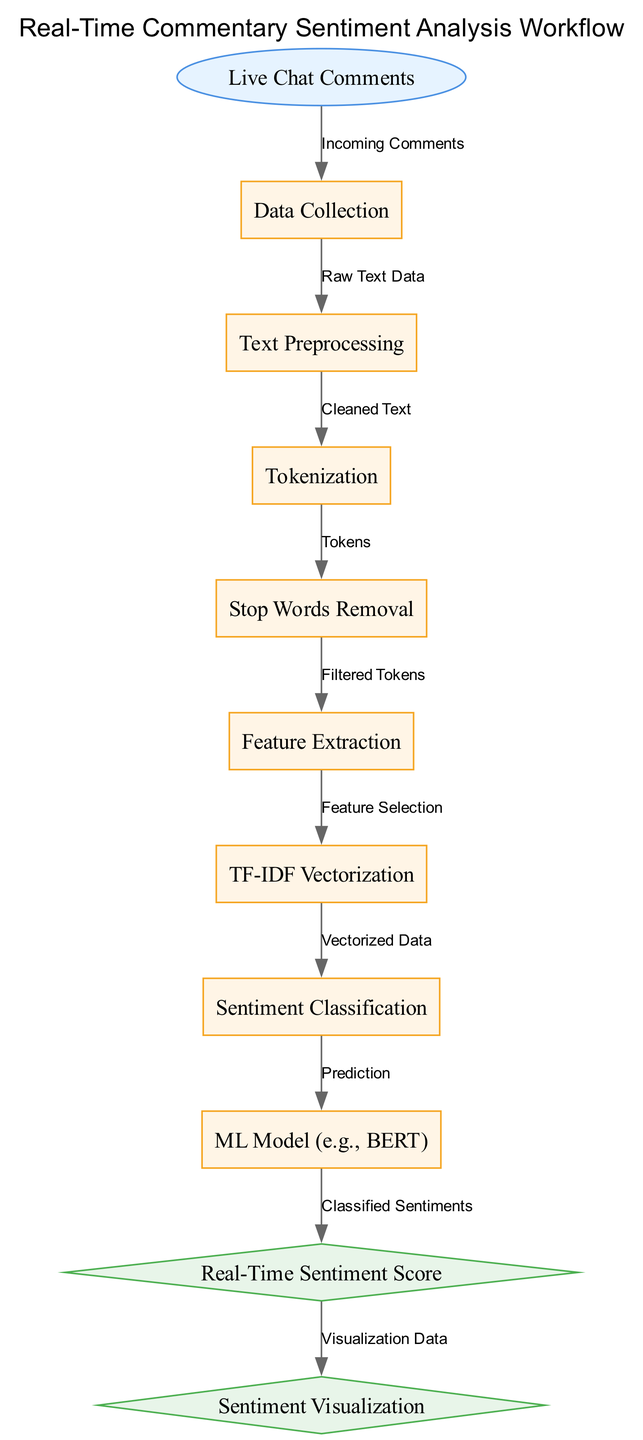What is the input for the sentiment analysis system? The diagram indicates that the input for the sentiment analysis system is "Live Chat Comments," which are collected from the streaming interface.
Answer: Live Chat Comments How many stages are there in the processing workflow? The diagram lists a total of eight processing stages: Data Collection, Text Preprocessing, Tokenization, Stop Words Removal, Feature Extraction, TF-IDF Vectorization, Sentiment Classification, and ML Model.
Answer: Eight What is used for feature extraction in the sentiment analysis? According to the diagram, "TF-IDF Vectorization" is the method used for feature extraction in this sentiment analysis workflow, transforming text data into a numerical format.
Answer: TF-IDF Vectorization Which node follows Stop Words Removal? The diagram shows that the node following "Stop Words Removal" is "Feature Extraction," indicating the flow from filtering tokens to selecting features for analysis.
Answer: Feature Extraction What type of output is produced after Sentiment Classification? The diagram details that the output produced after the "Sentiment Classification" process is "Real-Time Sentiment Score," showcasing the system's ability to provide immediate feedback on audience sentiment.
Answer: Real-Time Sentiment Score What are the final outputs of the workflow? The final outputs of the workflow, as depicted in the diagram, include "Real-Time Sentiment Score" and "Sentiment Visualization," which represent quantifiable sentiment and its graphic representation respectively.
Answer: Real-Time Sentiment Score, Sentiment Visualization Which process precedes the ML Model? In the workflow, the process that precedes the "ML Model" is the "Sentiment Classification,” which indicates that the classification step must be completed before applying the machine learning model for final predictions.
Answer: Sentiment Classification What does the edge from Node 5 to Node 6 represent? The edge connecting "Stop Words Removal" to "Feature Extraction" represents the progression of filtered tokens that are ready for the feature selection process in the analysis.
Answer: Filtered Tokens 